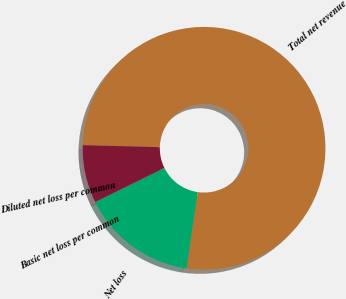Convert chart to OTSL. <chart><loc_0><loc_0><loc_500><loc_500><pie_chart><fcel>Total net revenue<fcel>Net loss<fcel>Basic net loss per common<fcel>Diluted net loss per common<nl><fcel>76.89%<fcel>15.39%<fcel>0.01%<fcel>7.7%<nl></chart> 